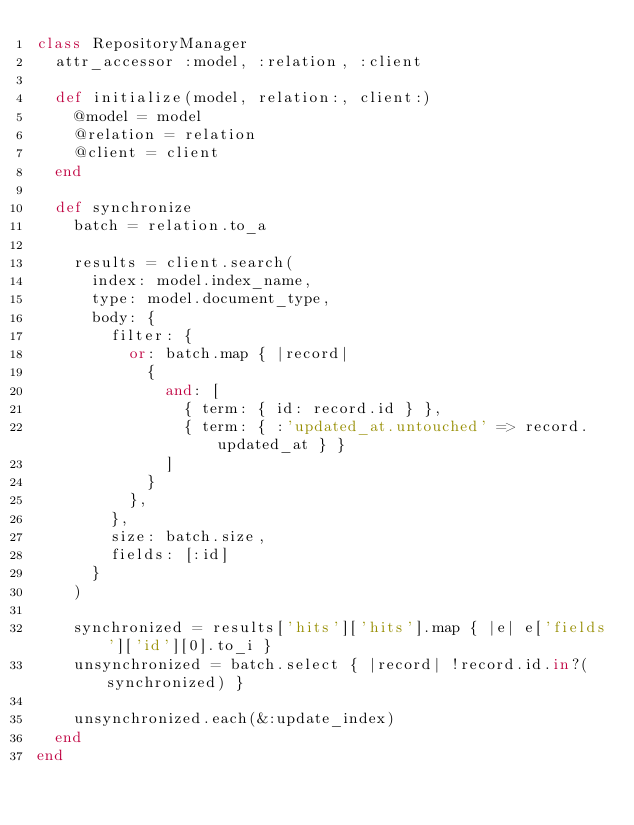Convert code to text. <code><loc_0><loc_0><loc_500><loc_500><_Ruby_>class RepositoryManager
  attr_accessor :model, :relation, :client

  def initialize(model, relation:, client:)
    @model = model
    @relation = relation
    @client = client
  end

  def synchronize
    batch = relation.to_a

    results = client.search(
      index: model.index_name,
      type: model.document_type,
      body: {
        filter: {
          or: batch.map { |record|
            {
              and: [
                { term: { id: record.id } },
                { term: { :'updated_at.untouched' => record.updated_at } }
              ]
            }
          },
        },
        size: batch.size,
        fields: [:id]
      }
    )

    synchronized = results['hits']['hits'].map { |e| e['fields']['id'][0].to_i }
    unsynchronized = batch.select { |record| !record.id.in?(synchronized) }

    unsynchronized.each(&:update_index)
  end
end
</code> 